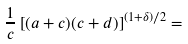<formula> <loc_0><loc_0><loc_500><loc_500>\frac { 1 } { c } \left [ ( a + c ) ( c + d ) \right ] ^ { ( 1 + \delta ) / 2 } =</formula> 